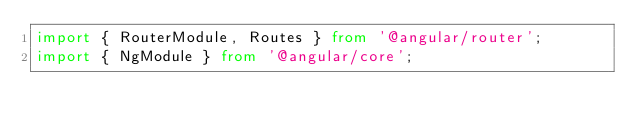Convert code to text. <code><loc_0><loc_0><loc_500><loc_500><_TypeScript_>import { RouterModule, Routes } from '@angular/router';
import { NgModule } from '@angular/core';
</code> 